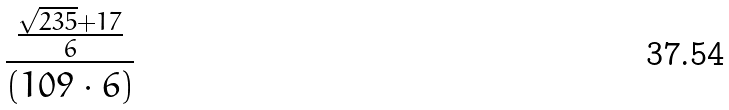Convert formula to latex. <formula><loc_0><loc_0><loc_500><loc_500>\frac { \frac { \sqrt { 2 3 5 } + 1 7 } { 6 } } { ( 1 0 9 \cdot 6 ) }</formula> 